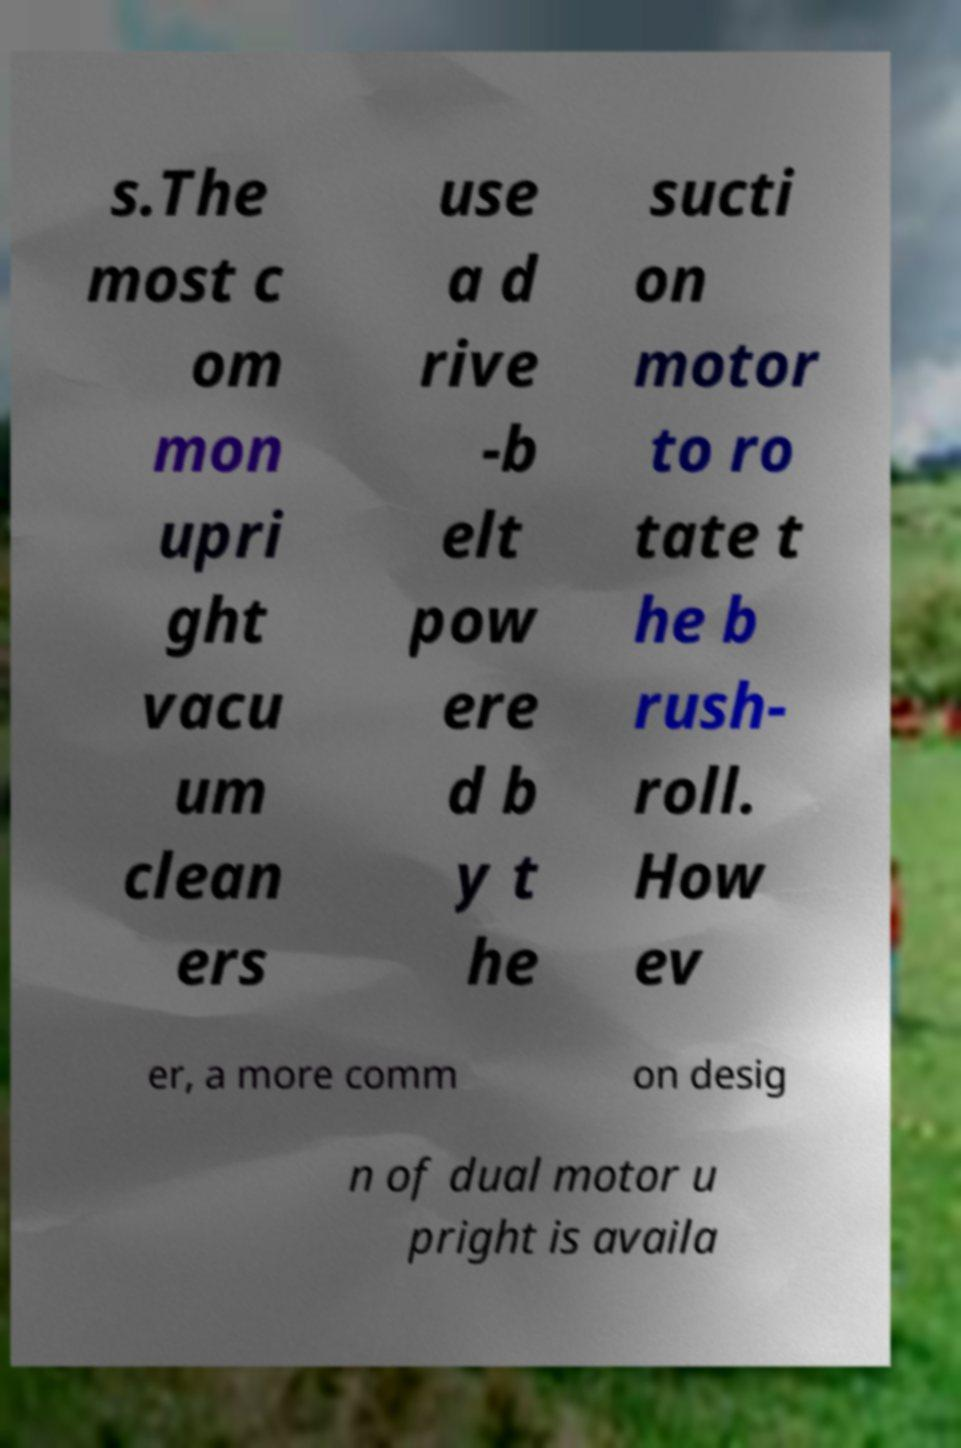Please identify and transcribe the text found in this image. s.The most c om mon upri ght vacu um clean ers use a d rive -b elt pow ere d b y t he sucti on motor to ro tate t he b rush- roll. How ev er, a more comm on desig n of dual motor u pright is availa 